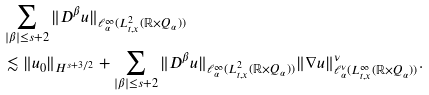Convert formula to latex. <formula><loc_0><loc_0><loc_500><loc_500>& \sum _ { | \beta | \leq s + 2 } \| D ^ { \beta } u \| _ { \ell ^ { \infty } _ { \alpha } ( L ^ { 2 } _ { t , x } ( \mathbb { R } \times Q _ { \alpha } ) ) } \\ & \lesssim \| u _ { 0 } \| _ { H ^ { s + 3 / 2 } } + \sum _ { | \beta | \leq s + 2 } \| D ^ { \beta } u \| _ { \ell ^ { \infty } _ { \alpha } ( L ^ { 2 } _ { t , x } ( \mathbb { R } \times Q _ { \alpha } ) ) } \| \nabla u \| ^ { \nu } _ { \ell ^ { \nu } _ { \alpha } ( L ^ { \infty } _ { t , x } ( \mathbb { R } \times Q _ { \alpha } ) ) } .</formula> 